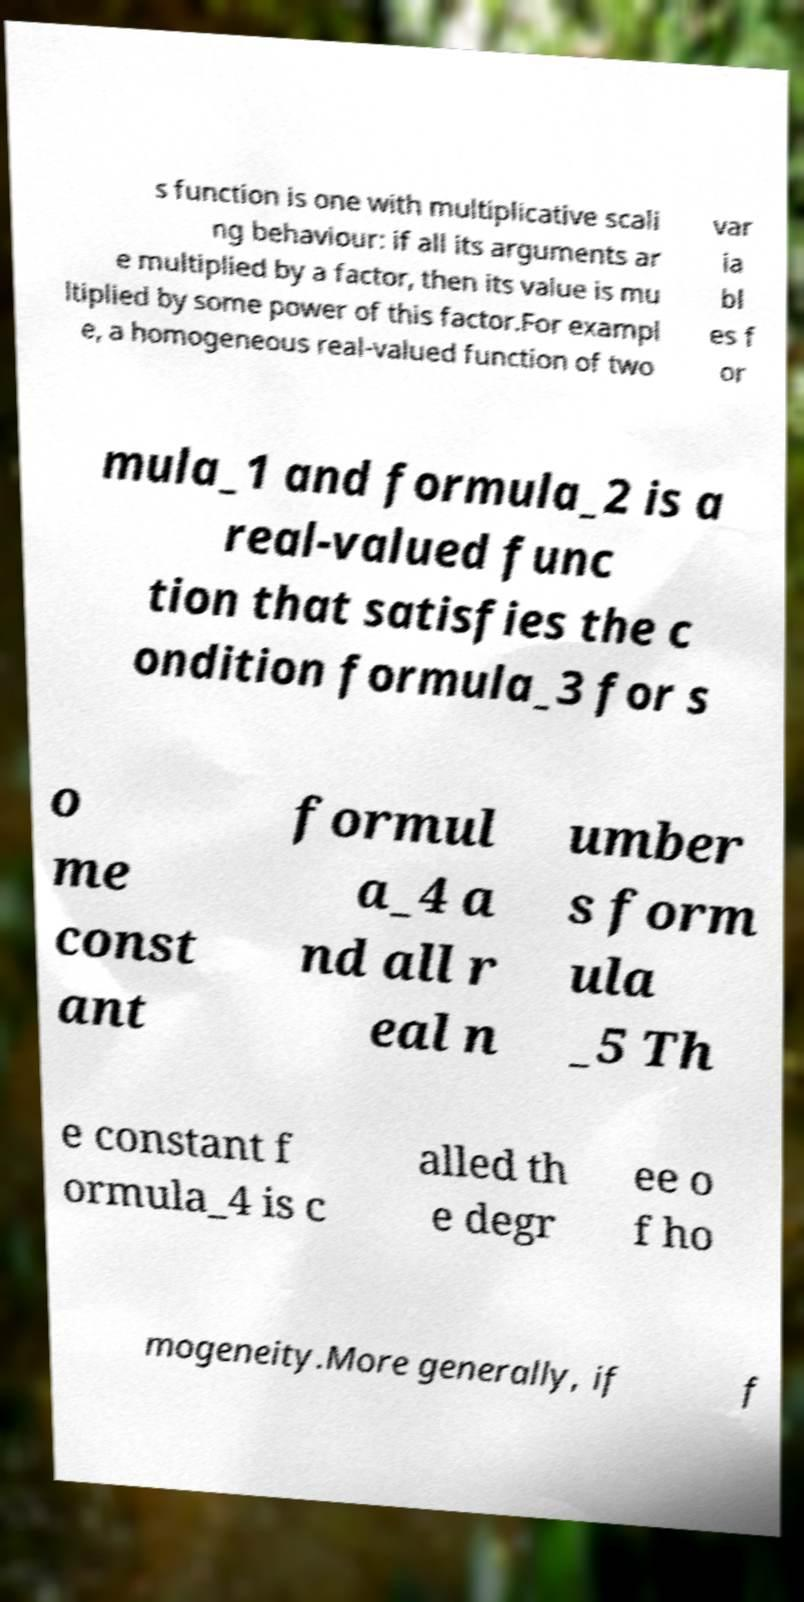Can you read and provide the text displayed in the image?This photo seems to have some interesting text. Can you extract and type it out for me? s function is one with multiplicative scali ng behaviour: if all its arguments ar e multiplied by a factor, then its value is mu ltiplied by some power of this factor.For exampl e, a homogeneous real-valued function of two var ia bl es f or mula_1 and formula_2 is a real-valued func tion that satisfies the c ondition formula_3 for s o me const ant formul a_4 a nd all r eal n umber s form ula _5 Th e constant f ormula_4 is c alled th e degr ee o f ho mogeneity.More generally, if f 